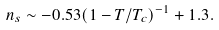Convert formula to latex. <formula><loc_0><loc_0><loc_500><loc_500>n _ { s } \sim - 0 . 5 3 ( 1 - T / T _ { c } ) ^ { - 1 } + 1 . 3 .</formula> 